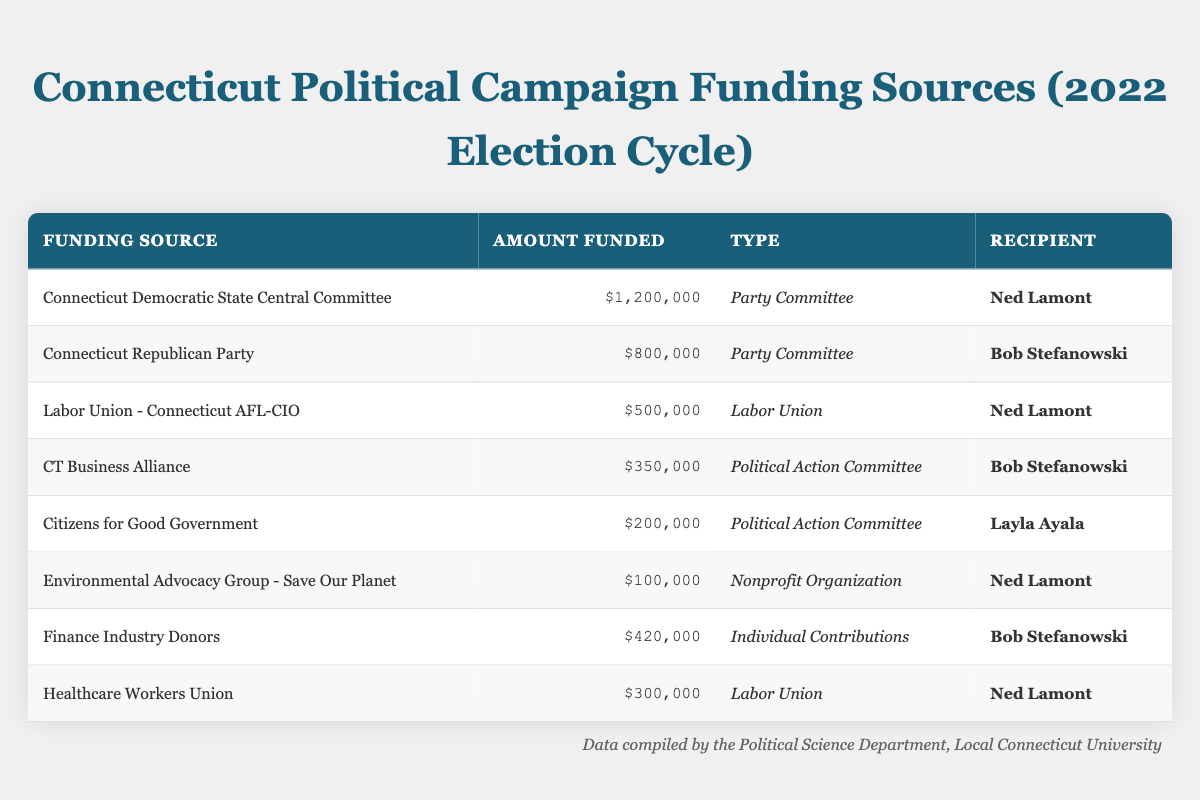What's the total amount funded to Ned Lamont? To find the total amount funded to Ned Lamont, I will add the amounts from the relevant rows: $1,200,000 (Connecticut Democratic State Central Committee) + $500,000 (Labor Union - Connecticut AFL-CIO) + $100,000 (Environmental Advocacy Group - Save Our Planet) + $300,000 (Healthcare Workers Union). Summing these amounts, we get $1,200,000 + $500,000 + $100,000 + $300,000 = $2,100,000.
Answer: $2,100,000 Which funding source contributed the most to Bob Stefanowski? Looking at the table, I see two contributions for Bob Stefanowski: $800,000 from the Connecticut Republican Party and $420,000 from Finance Industry Donors. The largest amount is $800,000.
Answer: $800,000 Did Citizens for Good Government contribute more than Environmental Advocacy Group - Save Our Planet? Citizens for Good Government contributed $200,000, while Environmental Advocacy Group - Save Our Planet contributed $100,000. Since $200,000 is greater than $100,000, the statement is true.
Answer: Yes How many different types of funding sources supported Ned Lamont? The types of funding sources for Ned Lamont are Party Committee (Connecticut Democratic State Central Committee), Labor Union (Connecticut AFL-CIO), Nonprofit Organization (Environmental Advocacy Group - Save Our Planet), and Labor Union (Healthcare Workers Union). There are 3 unique types of funding: Party Committee, Labor Union, and Nonprofit Organization.
Answer: 3 What’s the total amount funded from Labor Union sources? To find the total funding from Labor Unions, I need to add the relevant contributions: $500,000 (Labor Union - Connecticut AFL-CIO) + $300,000 (Healthcare Workers Union). This gives me $500,000 + $300,000 = $800,000.
Answer: $800,000 Is it true that the Connecticut Democratic State Central Committee funded more than all Political Action Committees combined? First, I will sum the contributions from Political Action Committees: $350,000 (CT Business Alliance) + $200,000 (Citizens for Good Government) = $550,000. The Connecticut Democratic State Central Committee funded $1,200,000, which is greater than $550,000, making the statement true.
Answer: Yes Which candidate received the least amount of funding overall? I will calculate the total funding for each candidate: Ned Lamont: $2,100,000, Bob Stefanowski: $1,220,000 ($800,000 + $420,000), Layla Ayala: $200,000. Comparing these totals, Layla Ayala received the least funding.
Answer: Layla Ayala How much more did Connecticut Democratic State Central Committee fund than Finance Industry Donors? The amount funded by the Connecticut Democratic State Central Committee is $1,200,000, and Finance Industry Donors contributed $420,000. I will take the difference: $1,200,000 - $420,000 = $780,000.
Answer: $780,000 